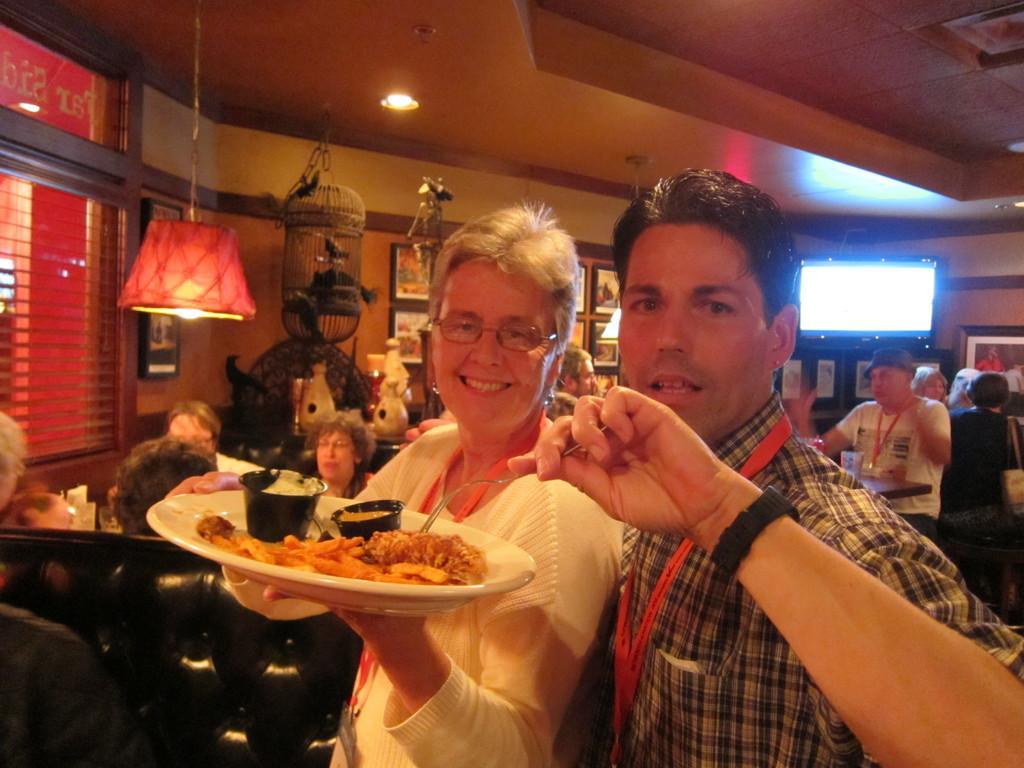Could you give a brief overview of what you see in this image? In the picture we can see a man and a woman standing together and woman is smiling and holding a plate in the hand with some food items in it and behind them we can see some people are sitting in the chairs near the tables and in the background we can see a wall with some photo frames and beside it we can see a TV and to the ceiling we can see a hanging lamp and some lights to it and we can see a cage of a bird is hanged to the ceiling with a bird in it. 